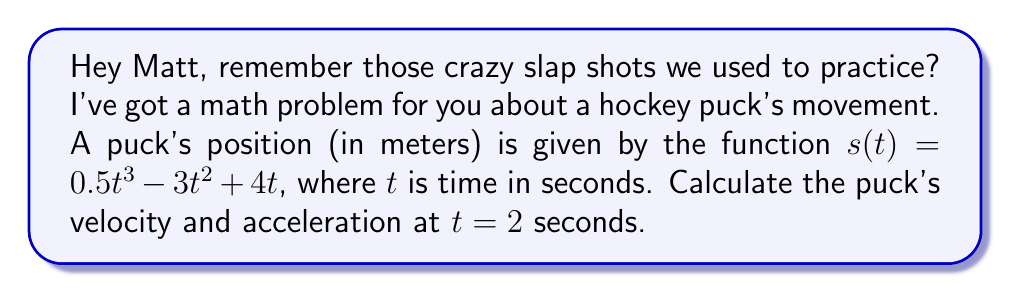Teach me how to tackle this problem. To solve this problem, we need to use calculus to find the velocity and acceleration functions, then evaluate them at the given time.

1. Velocity function:
The velocity is the first derivative of the position function.
$$v(t) = \frac{d}{dt}s(t) = \frac{d}{dt}(0.5t^3 - 3t^2 + 4t)$$
$$v(t) = 1.5t^2 - 6t + 4$$

2. Acceleration function:
The acceleration is the second derivative of the position function, or the first derivative of the velocity function.
$$a(t) = \frac{d}{dt}v(t) = \frac{d}{dt}(1.5t^2 - 6t + 4)$$
$$a(t) = 3t - 6$$

3. Calculating velocity at $t = 2$ seconds:
$$v(2) = 1.5(2)^2 - 6(2) + 4$$
$$v(2) = 1.5(4) - 12 + 4 = 6 - 12 + 4 = -2$$

4. Calculating acceleration at $t = 2$ seconds:
$$a(2) = 3(2) - 6$$
$$a(2) = 6 - 6 = 0$$
Answer: At $t = 2$ seconds:
Velocity: $-2$ m/s
Acceleration: $0$ m/s² 